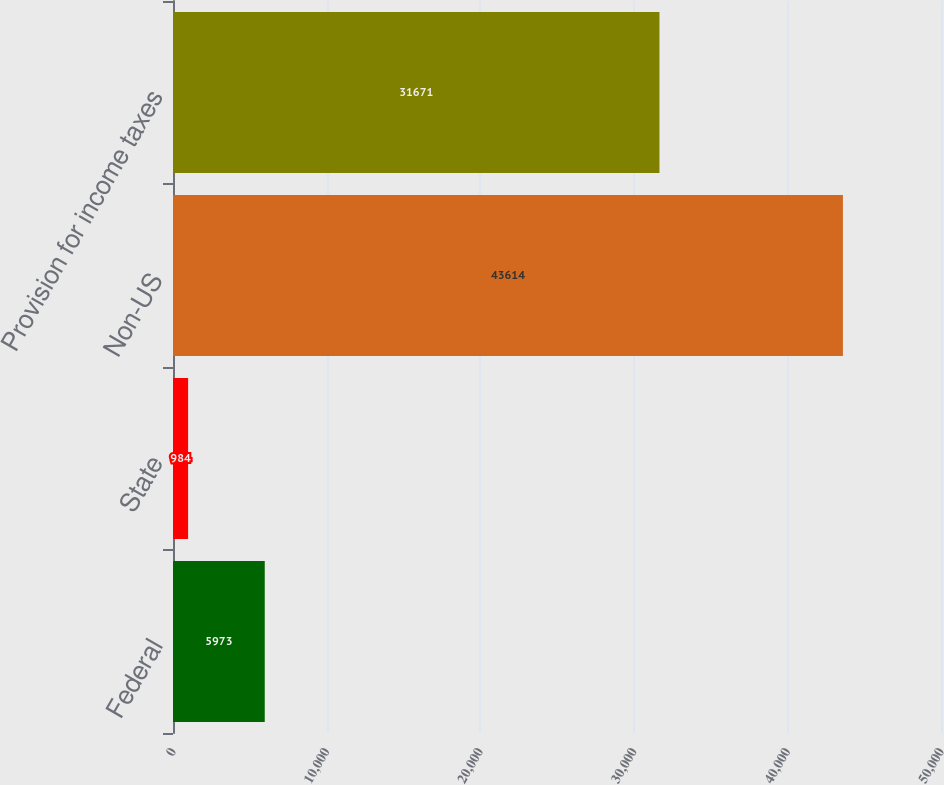Convert chart to OTSL. <chart><loc_0><loc_0><loc_500><loc_500><bar_chart><fcel>Federal<fcel>State<fcel>Non-US<fcel>Provision for income taxes<nl><fcel>5973<fcel>984<fcel>43614<fcel>31671<nl></chart> 